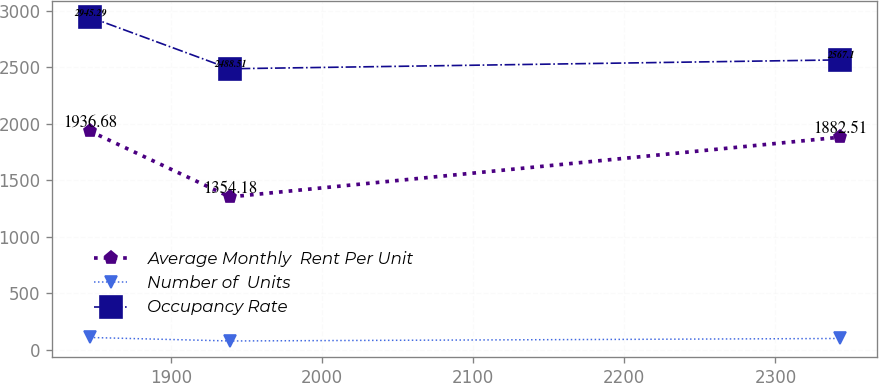Convert chart. <chart><loc_0><loc_0><loc_500><loc_500><line_chart><ecel><fcel>Average Monthly  Rent Per Unit<fcel>Number of  Units<fcel>Occupancy Rate<nl><fcel>1846.44<fcel>1936.68<fcel>109.67<fcel>2945.29<nl><fcel>1939.05<fcel>1354.18<fcel>78.81<fcel>2488.51<nl><fcel>2342.5<fcel>1882.51<fcel>100.86<fcel>2567.1<nl></chart> 